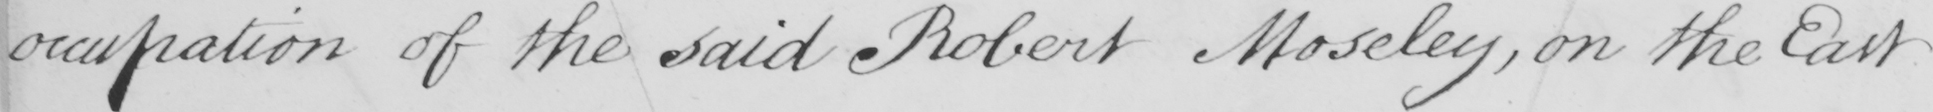What is written in this line of handwriting? occupation of the said Robert Moseley , on the East 